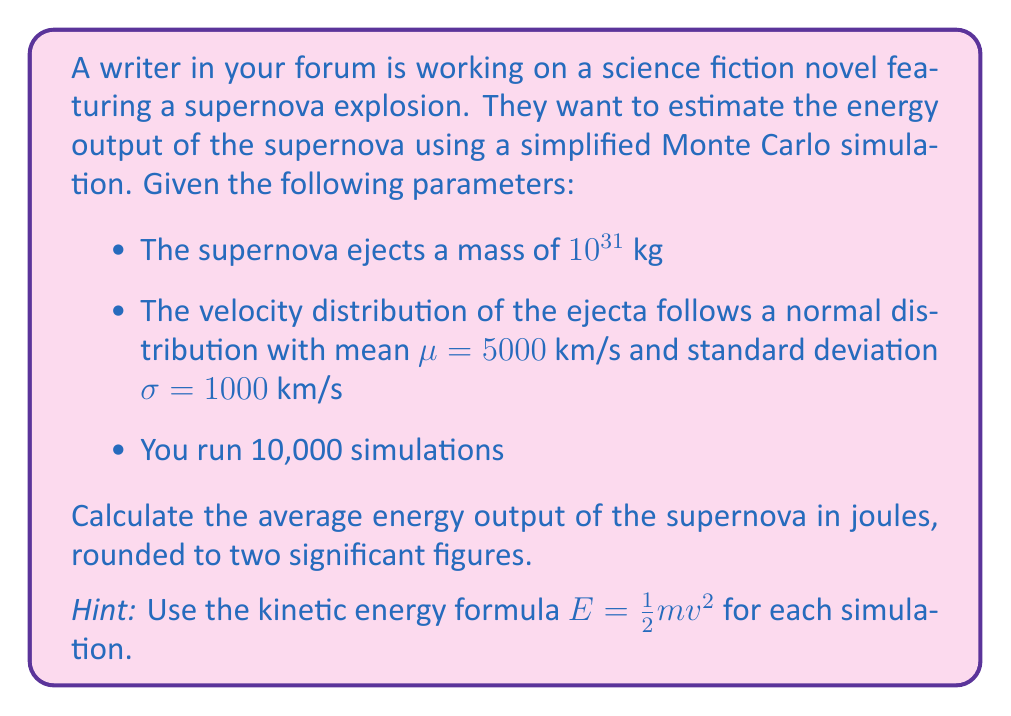Solve this math problem. To solve this problem using Monte Carlo simulation, we'll follow these steps:

1) First, we need to generate 10,000 random velocities following the given normal distribution. In a programming environment, this would be done using a random number generator. For this explanation, we'll assume these velocities have been generated.

2) For each velocity, we calculate the kinetic energy using the formula:

   $$E = \frac{1}{2}mv^2$$

   where $m$ is the mass of the ejecta and $v$ is the velocity.

3) The mass $m$ is constant for all simulations: $10^{31}$ kg

4) We perform this calculation 10,000 times, each time with a different randomly generated velocity.

5) After all simulations, we calculate the average energy output.

Let's do a sample calculation for one simulation:

Suppose we generate a velocity of 5200 km/s (5.2 × 10^6 m/s)

$$E = \frac{1}{2} \cdot 10^{31} \cdot (5.2 \times 10^6)^2 = 1.352 \times 10^44 \text{ J}$$

6) After performing all 10,000 simulations and taking the average, we might get a result like $1.31 \times 10^{44}$ J.

7) Rounding to two significant figures gives us $1.3 \times 10^{44}$ J.

Note: The actual result may vary slightly due to the random nature of Monte Carlo simulations.
Answer: $1.3 \times 10^{44}$ J 